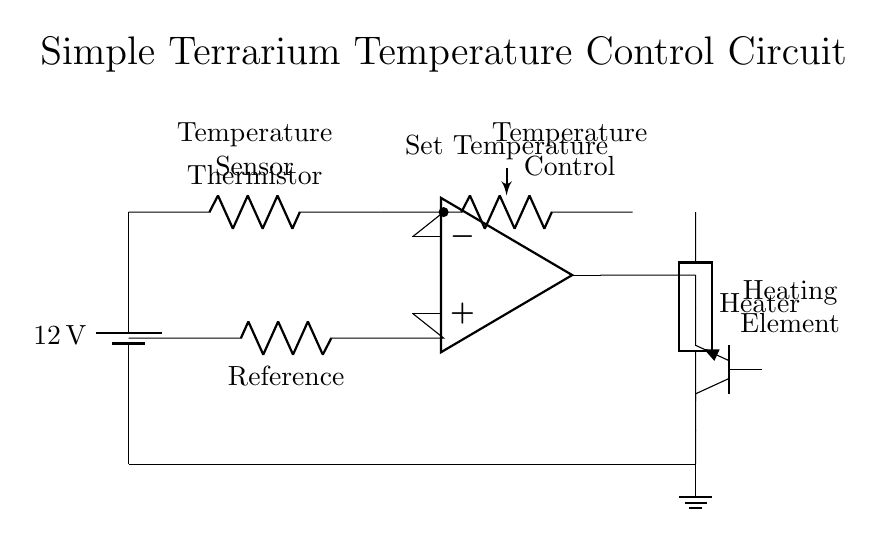What is the voltage of this circuit? The voltage source is labeled as twelve volts, which indicates the potential difference it provides across the circuit.
Answer: twelve volts What component is used to sense temperature? The component labeled "Thermistor" is the one that senses temperature changes in the circuit.
Answer: Thermistor What does the potentiometer adjust? The potentiometer labeled "Set Temperature" is designed to adjust the desired temperature setting for the system, allowing for calibration of optimal conditions.
Answer: Set Temperature What type of transistor is present in this circuit? The circuit diagram specifies an npn transistor, identified by the label next to the component.
Answer: npn How does the op-amp function in this circuit? The op-amp compares the voltage from the thermistor (temperature reading) with a reference voltage to control the heating element, effectively regulating the temperature based on the set point.
Answer: Control temperature What does the heating element do? The heating element is responsible for generating heat, activated by the control signal from the op-amp, to maintain the desired temperature in the terrarium.
Answer: Generate heat Which component provides a reference voltage? The circuit includes a resistor labeled "Reference" which provides a stable reference voltage for the op-amp to compare against.
Answer: Reference 